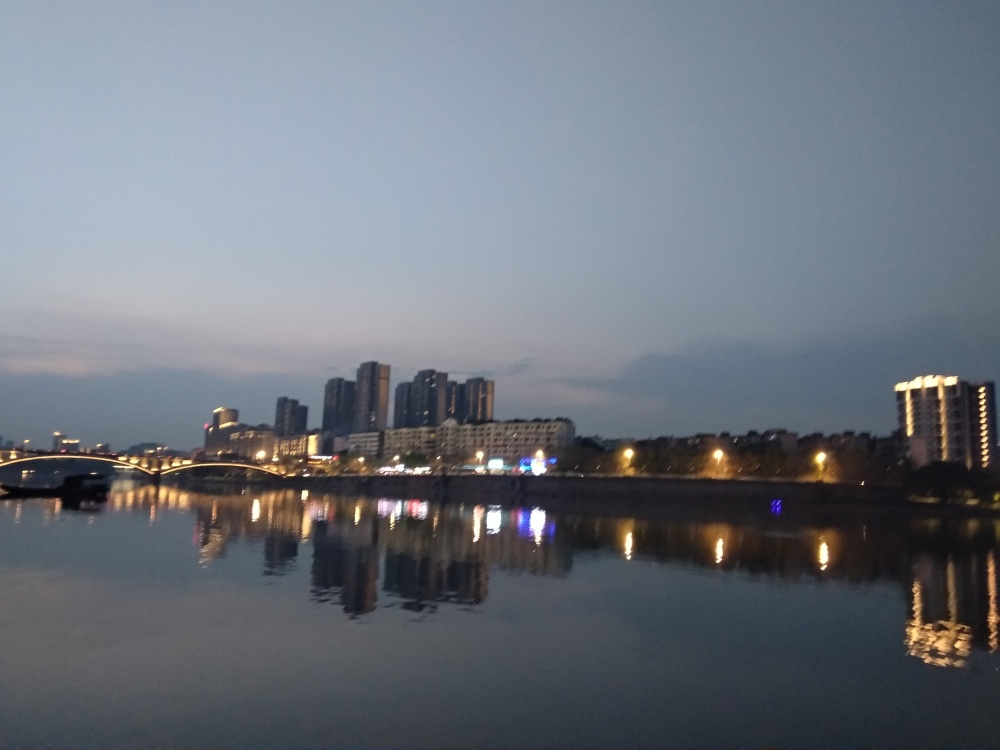Is the quality of this image acceptable? The image's quality can be considered acceptable with some reservations. It captures the cityscape's reflection over water during twilight, providing a serene visual. However, the focus appears soft, and there's visible noise in the low-light conditions, which are aspects that could be improved for a sharper and clearer image. 